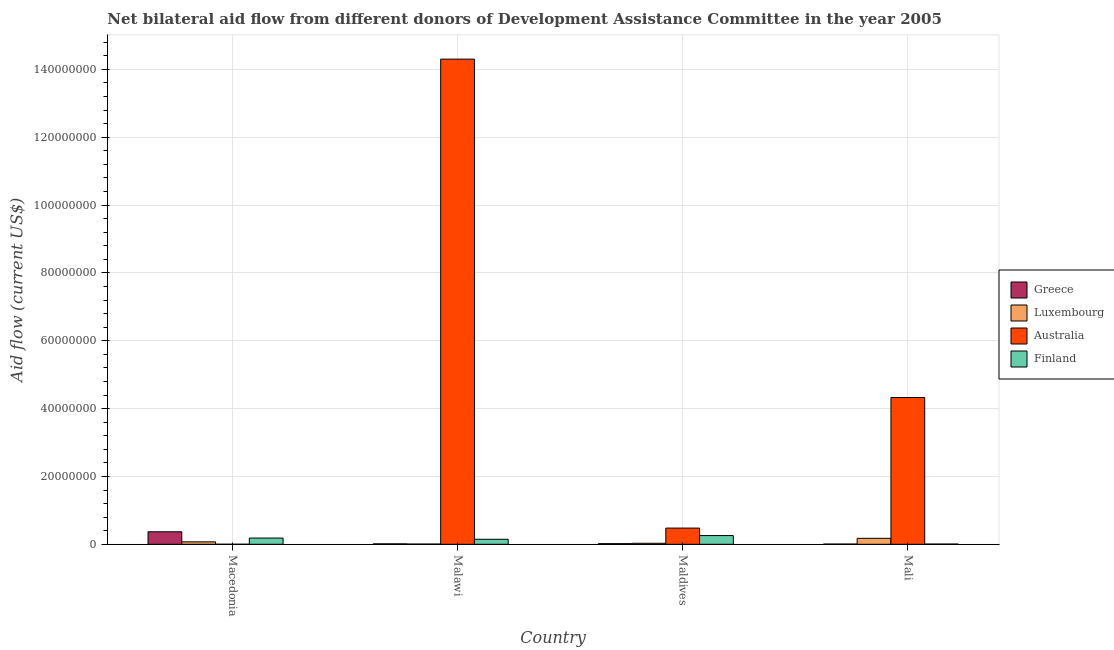Are the number of bars on each tick of the X-axis equal?
Keep it short and to the point. Yes. What is the label of the 2nd group of bars from the left?
Your answer should be very brief. Malawi. In how many cases, is the number of bars for a given country not equal to the number of legend labels?
Offer a very short reply. 0. What is the amount of aid given by finland in Macedonia?
Your answer should be compact. 1.84e+06. Across all countries, what is the maximum amount of aid given by australia?
Your answer should be very brief. 1.43e+08. Across all countries, what is the minimum amount of aid given by greece?
Your response must be concise. 7.00e+04. In which country was the amount of aid given by australia maximum?
Your answer should be compact. Malawi. In which country was the amount of aid given by finland minimum?
Your answer should be very brief. Mali. What is the total amount of aid given by australia in the graph?
Offer a very short reply. 1.91e+08. What is the difference between the amount of aid given by greece in Macedonia and that in Mali?
Your response must be concise. 3.62e+06. What is the difference between the amount of aid given by greece in Malawi and the amount of aid given by finland in Macedonia?
Offer a terse response. -1.71e+06. What is the average amount of aid given by greece per country?
Your answer should be compact. 1.02e+06. What is the difference between the amount of aid given by australia and amount of aid given by greece in Malawi?
Make the answer very short. 1.43e+08. In how many countries, is the amount of aid given by luxembourg greater than 124000000 US$?
Offer a terse response. 0. What is the ratio of the amount of aid given by finland in Macedonia to that in Malawi?
Offer a terse response. 1.24. What is the difference between the highest and the second highest amount of aid given by finland?
Provide a short and direct response. 7.30e+05. What is the difference between the highest and the lowest amount of aid given by finland?
Give a very brief answer. 2.50e+06. In how many countries, is the amount of aid given by finland greater than the average amount of aid given by finland taken over all countries?
Provide a short and direct response. 2. Is it the case that in every country, the sum of the amount of aid given by greece and amount of aid given by finland is greater than the sum of amount of aid given by luxembourg and amount of aid given by australia?
Your answer should be very brief. No. What does the 2nd bar from the right in Macedonia represents?
Offer a very short reply. Australia. Is it the case that in every country, the sum of the amount of aid given by greece and amount of aid given by luxembourg is greater than the amount of aid given by australia?
Your answer should be compact. No. How many bars are there?
Your answer should be very brief. 16. Are all the bars in the graph horizontal?
Your answer should be compact. No. How many countries are there in the graph?
Your answer should be very brief. 4. What is the difference between two consecutive major ticks on the Y-axis?
Your response must be concise. 2.00e+07. Does the graph contain any zero values?
Make the answer very short. No. Does the graph contain grids?
Give a very brief answer. Yes. How many legend labels are there?
Provide a short and direct response. 4. What is the title of the graph?
Your response must be concise. Net bilateral aid flow from different donors of Development Assistance Committee in the year 2005. Does "Trade" appear as one of the legend labels in the graph?
Keep it short and to the point. No. What is the label or title of the Y-axis?
Make the answer very short. Aid flow (current US$). What is the Aid flow (current US$) in Greece in Macedonia?
Ensure brevity in your answer.  3.69e+06. What is the Aid flow (current US$) of Luxembourg in Macedonia?
Provide a short and direct response. 7.20e+05. What is the Aid flow (current US$) of Australia in Macedonia?
Make the answer very short. 10000. What is the Aid flow (current US$) in Finland in Macedonia?
Make the answer very short. 1.84e+06. What is the Aid flow (current US$) in Greece in Malawi?
Offer a terse response. 1.30e+05. What is the Aid flow (current US$) in Luxembourg in Malawi?
Keep it short and to the point. 7.00e+04. What is the Aid flow (current US$) in Australia in Malawi?
Offer a terse response. 1.43e+08. What is the Aid flow (current US$) of Finland in Malawi?
Provide a short and direct response. 1.48e+06. What is the Aid flow (current US$) in Australia in Maldives?
Your answer should be compact. 4.78e+06. What is the Aid flow (current US$) in Finland in Maldives?
Your response must be concise. 2.57e+06. What is the Aid flow (current US$) in Luxembourg in Mali?
Offer a very short reply. 1.76e+06. What is the Aid flow (current US$) in Australia in Mali?
Your answer should be very brief. 4.33e+07. What is the Aid flow (current US$) in Finland in Mali?
Offer a very short reply. 7.00e+04. Across all countries, what is the maximum Aid flow (current US$) in Greece?
Ensure brevity in your answer.  3.69e+06. Across all countries, what is the maximum Aid flow (current US$) of Luxembourg?
Offer a terse response. 1.76e+06. Across all countries, what is the maximum Aid flow (current US$) of Australia?
Keep it short and to the point. 1.43e+08. Across all countries, what is the maximum Aid flow (current US$) of Finland?
Ensure brevity in your answer.  2.57e+06. Across all countries, what is the minimum Aid flow (current US$) in Greece?
Offer a very short reply. 7.00e+04. Across all countries, what is the minimum Aid flow (current US$) in Australia?
Provide a succinct answer. 10000. Across all countries, what is the minimum Aid flow (current US$) in Finland?
Provide a succinct answer. 7.00e+04. What is the total Aid flow (current US$) in Greece in the graph?
Offer a very short reply. 4.08e+06. What is the total Aid flow (current US$) of Luxembourg in the graph?
Ensure brevity in your answer.  2.85e+06. What is the total Aid flow (current US$) in Australia in the graph?
Keep it short and to the point. 1.91e+08. What is the total Aid flow (current US$) in Finland in the graph?
Offer a terse response. 5.96e+06. What is the difference between the Aid flow (current US$) of Greece in Macedonia and that in Malawi?
Offer a terse response. 3.56e+06. What is the difference between the Aid flow (current US$) of Luxembourg in Macedonia and that in Malawi?
Ensure brevity in your answer.  6.50e+05. What is the difference between the Aid flow (current US$) of Australia in Macedonia and that in Malawi?
Provide a succinct answer. -1.43e+08. What is the difference between the Aid flow (current US$) of Greece in Macedonia and that in Maldives?
Your answer should be compact. 3.50e+06. What is the difference between the Aid flow (current US$) of Luxembourg in Macedonia and that in Maldives?
Give a very brief answer. 4.20e+05. What is the difference between the Aid flow (current US$) in Australia in Macedonia and that in Maldives?
Ensure brevity in your answer.  -4.77e+06. What is the difference between the Aid flow (current US$) of Finland in Macedonia and that in Maldives?
Give a very brief answer. -7.30e+05. What is the difference between the Aid flow (current US$) in Greece in Macedonia and that in Mali?
Give a very brief answer. 3.62e+06. What is the difference between the Aid flow (current US$) in Luxembourg in Macedonia and that in Mali?
Your response must be concise. -1.04e+06. What is the difference between the Aid flow (current US$) in Australia in Macedonia and that in Mali?
Provide a short and direct response. -4.33e+07. What is the difference between the Aid flow (current US$) of Finland in Macedonia and that in Mali?
Ensure brevity in your answer.  1.77e+06. What is the difference between the Aid flow (current US$) in Luxembourg in Malawi and that in Maldives?
Keep it short and to the point. -2.30e+05. What is the difference between the Aid flow (current US$) of Australia in Malawi and that in Maldives?
Your response must be concise. 1.38e+08. What is the difference between the Aid flow (current US$) of Finland in Malawi and that in Maldives?
Your response must be concise. -1.09e+06. What is the difference between the Aid flow (current US$) of Greece in Malawi and that in Mali?
Provide a succinct answer. 6.00e+04. What is the difference between the Aid flow (current US$) of Luxembourg in Malawi and that in Mali?
Keep it short and to the point. -1.69e+06. What is the difference between the Aid flow (current US$) in Australia in Malawi and that in Mali?
Provide a succinct answer. 9.98e+07. What is the difference between the Aid flow (current US$) in Finland in Malawi and that in Mali?
Offer a terse response. 1.41e+06. What is the difference between the Aid flow (current US$) of Greece in Maldives and that in Mali?
Keep it short and to the point. 1.20e+05. What is the difference between the Aid flow (current US$) in Luxembourg in Maldives and that in Mali?
Offer a terse response. -1.46e+06. What is the difference between the Aid flow (current US$) of Australia in Maldives and that in Mali?
Keep it short and to the point. -3.85e+07. What is the difference between the Aid flow (current US$) of Finland in Maldives and that in Mali?
Your answer should be very brief. 2.50e+06. What is the difference between the Aid flow (current US$) in Greece in Macedonia and the Aid flow (current US$) in Luxembourg in Malawi?
Provide a succinct answer. 3.62e+06. What is the difference between the Aid flow (current US$) in Greece in Macedonia and the Aid flow (current US$) in Australia in Malawi?
Provide a succinct answer. -1.39e+08. What is the difference between the Aid flow (current US$) of Greece in Macedonia and the Aid flow (current US$) of Finland in Malawi?
Offer a very short reply. 2.21e+06. What is the difference between the Aid flow (current US$) in Luxembourg in Macedonia and the Aid flow (current US$) in Australia in Malawi?
Your response must be concise. -1.42e+08. What is the difference between the Aid flow (current US$) in Luxembourg in Macedonia and the Aid flow (current US$) in Finland in Malawi?
Make the answer very short. -7.60e+05. What is the difference between the Aid flow (current US$) in Australia in Macedonia and the Aid flow (current US$) in Finland in Malawi?
Your response must be concise. -1.47e+06. What is the difference between the Aid flow (current US$) of Greece in Macedonia and the Aid flow (current US$) of Luxembourg in Maldives?
Provide a short and direct response. 3.39e+06. What is the difference between the Aid flow (current US$) in Greece in Macedonia and the Aid flow (current US$) in Australia in Maldives?
Offer a very short reply. -1.09e+06. What is the difference between the Aid flow (current US$) in Greece in Macedonia and the Aid flow (current US$) in Finland in Maldives?
Provide a succinct answer. 1.12e+06. What is the difference between the Aid flow (current US$) of Luxembourg in Macedonia and the Aid flow (current US$) of Australia in Maldives?
Offer a terse response. -4.06e+06. What is the difference between the Aid flow (current US$) in Luxembourg in Macedonia and the Aid flow (current US$) in Finland in Maldives?
Provide a short and direct response. -1.85e+06. What is the difference between the Aid flow (current US$) of Australia in Macedonia and the Aid flow (current US$) of Finland in Maldives?
Offer a very short reply. -2.56e+06. What is the difference between the Aid flow (current US$) of Greece in Macedonia and the Aid flow (current US$) of Luxembourg in Mali?
Provide a succinct answer. 1.93e+06. What is the difference between the Aid flow (current US$) in Greece in Macedonia and the Aid flow (current US$) in Australia in Mali?
Your answer should be compact. -3.96e+07. What is the difference between the Aid flow (current US$) of Greece in Macedonia and the Aid flow (current US$) of Finland in Mali?
Your answer should be very brief. 3.62e+06. What is the difference between the Aid flow (current US$) in Luxembourg in Macedonia and the Aid flow (current US$) in Australia in Mali?
Provide a succinct answer. -4.26e+07. What is the difference between the Aid flow (current US$) in Luxembourg in Macedonia and the Aid flow (current US$) in Finland in Mali?
Provide a short and direct response. 6.50e+05. What is the difference between the Aid flow (current US$) in Greece in Malawi and the Aid flow (current US$) in Australia in Maldives?
Provide a succinct answer. -4.65e+06. What is the difference between the Aid flow (current US$) in Greece in Malawi and the Aid flow (current US$) in Finland in Maldives?
Give a very brief answer. -2.44e+06. What is the difference between the Aid flow (current US$) of Luxembourg in Malawi and the Aid flow (current US$) of Australia in Maldives?
Your response must be concise. -4.71e+06. What is the difference between the Aid flow (current US$) of Luxembourg in Malawi and the Aid flow (current US$) of Finland in Maldives?
Ensure brevity in your answer.  -2.50e+06. What is the difference between the Aid flow (current US$) of Australia in Malawi and the Aid flow (current US$) of Finland in Maldives?
Provide a short and direct response. 1.40e+08. What is the difference between the Aid flow (current US$) in Greece in Malawi and the Aid flow (current US$) in Luxembourg in Mali?
Make the answer very short. -1.63e+06. What is the difference between the Aid flow (current US$) in Greece in Malawi and the Aid flow (current US$) in Australia in Mali?
Provide a short and direct response. -4.31e+07. What is the difference between the Aid flow (current US$) of Luxembourg in Malawi and the Aid flow (current US$) of Australia in Mali?
Ensure brevity in your answer.  -4.32e+07. What is the difference between the Aid flow (current US$) of Australia in Malawi and the Aid flow (current US$) of Finland in Mali?
Provide a short and direct response. 1.43e+08. What is the difference between the Aid flow (current US$) in Greece in Maldives and the Aid flow (current US$) in Luxembourg in Mali?
Offer a very short reply. -1.57e+06. What is the difference between the Aid flow (current US$) in Greece in Maldives and the Aid flow (current US$) in Australia in Mali?
Ensure brevity in your answer.  -4.31e+07. What is the difference between the Aid flow (current US$) of Greece in Maldives and the Aid flow (current US$) of Finland in Mali?
Give a very brief answer. 1.20e+05. What is the difference between the Aid flow (current US$) in Luxembourg in Maldives and the Aid flow (current US$) in Australia in Mali?
Give a very brief answer. -4.30e+07. What is the difference between the Aid flow (current US$) in Luxembourg in Maldives and the Aid flow (current US$) in Finland in Mali?
Provide a succinct answer. 2.30e+05. What is the difference between the Aid flow (current US$) of Australia in Maldives and the Aid flow (current US$) of Finland in Mali?
Provide a succinct answer. 4.71e+06. What is the average Aid flow (current US$) in Greece per country?
Keep it short and to the point. 1.02e+06. What is the average Aid flow (current US$) in Luxembourg per country?
Offer a terse response. 7.12e+05. What is the average Aid flow (current US$) of Australia per country?
Provide a succinct answer. 4.78e+07. What is the average Aid flow (current US$) in Finland per country?
Give a very brief answer. 1.49e+06. What is the difference between the Aid flow (current US$) in Greece and Aid flow (current US$) in Luxembourg in Macedonia?
Keep it short and to the point. 2.97e+06. What is the difference between the Aid flow (current US$) of Greece and Aid flow (current US$) of Australia in Macedonia?
Give a very brief answer. 3.68e+06. What is the difference between the Aid flow (current US$) of Greece and Aid flow (current US$) of Finland in Macedonia?
Your answer should be very brief. 1.85e+06. What is the difference between the Aid flow (current US$) of Luxembourg and Aid flow (current US$) of Australia in Macedonia?
Your answer should be very brief. 7.10e+05. What is the difference between the Aid flow (current US$) of Luxembourg and Aid flow (current US$) of Finland in Macedonia?
Make the answer very short. -1.12e+06. What is the difference between the Aid flow (current US$) of Australia and Aid flow (current US$) of Finland in Macedonia?
Provide a succinct answer. -1.83e+06. What is the difference between the Aid flow (current US$) of Greece and Aid flow (current US$) of Luxembourg in Malawi?
Your answer should be compact. 6.00e+04. What is the difference between the Aid flow (current US$) in Greece and Aid flow (current US$) in Australia in Malawi?
Keep it short and to the point. -1.43e+08. What is the difference between the Aid flow (current US$) of Greece and Aid flow (current US$) of Finland in Malawi?
Give a very brief answer. -1.35e+06. What is the difference between the Aid flow (current US$) of Luxembourg and Aid flow (current US$) of Australia in Malawi?
Offer a very short reply. -1.43e+08. What is the difference between the Aid flow (current US$) in Luxembourg and Aid flow (current US$) in Finland in Malawi?
Your answer should be compact. -1.41e+06. What is the difference between the Aid flow (current US$) of Australia and Aid flow (current US$) of Finland in Malawi?
Your answer should be very brief. 1.42e+08. What is the difference between the Aid flow (current US$) of Greece and Aid flow (current US$) of Luxembourg in Maldives?
Offer a very short reply. -1.10e+05. What is the difference between the Aid flow (current US$) in Greece and Aid flow (current US$) in Australia in Maldives?
Your response must be concise. -4.59e+06. What is the difference between the Aid flow (current US$) in Greece and Aid flow (current US$) in Finland in Maldives?
Provide a short and direct response. -2.38e+06. What is the difference between the Aid flow (current US$) in Luxembourg and Aid flow (current US$) in Australia in Maldives?
Offer a terse response. -4.48e+06. What is the difference between the Aid flow (current US$) of Luxembourg and Aid flow (current US$) of Finland in Maldives?
Offer a very short reply. -2.27e+06. What is the difference between the Aid flow (current US$) of Australia and Aid flow (current US$) of Finland in Maldives?
Ensure brevity in your answer.  2.21e+06. What is the difference between the Aid flow (current US$) in Greece and Aid flow (current US$) in Luxembourg in Mali?
Your response must be concise. -1.69e+06. What is the difference between the Aid flow (current US$) in Greece and Aid flow (current US$) in Australia in Mali?
Provide a short and direct response. -4.32e+07. What is the difference between the Aid flow (current US$) of Luxembourg and Aid flow (current US$) of Australia in Mali?
Your answer should be compact. -4.15e+07. What is the difference between the Aid flow (current US$) in Luxembourg and Aid flow (current US$) in Finland in Mali?
Provide a short and direct response. 1.69e+06. What is the difference between the Aid flow (current US$) of Australia and Aid flow (current US$) of Finland in Mali?
Your answer should be compact. 4.32e+07. What is the ratio of the Aid flow (current US$) in Greece in Macedonia to that in Malawi?
Provide a short and direct response. 28.38. What is the ratio of the Aid flow (current US$) of Luxembourg in Macedonia to that in Malawi?
Provide a succinct answer. 10.29. What is the ratio of the Aid flow (current US$) in Australia in Macedonia to that in Malawi?
Your answer should be very brief. 0. What is the ratio of the Aid flow (current US$) of Finland in Macedonia to that in Malawi?
Keep it short and to the point. 1.24. What is the ratio of the Aid flow (current US$) of Greece in Macedonia to that in Maldives?
Your answer should be very brief. 19.42. What is the ratio of the Aid flow (current US$) in Australia in Macedonia to that in Maldives?
Make the answer very short. 0. What is the ratio of the Aid flow (current US$) in Finland in Macedonia to that in Maldives?
Provide a succinct answer. 0.72. What is the ratio of the Aid flow (current US$) in Greece in Macedonia to that in Mali?
Offer a terse response. 52.71. What is the ratio of the Aid flow (current US$) in Luxembourg in Macedonia to that in Mali?
Your answer should be very brief. 0.41. What is the ratio of the Aid flow (current US$) of Finland in Macedonia to that in Mali?
Your answer should be compact. 26.29. What is the ratio of the Aid flow (current US$) of Greece in Malawi to that in Maldives?
Your answer should be very brief. 0.68. What is the ratio of the Aid flow (current US$) of Luxembourg in Malawi to that in Maldives?
Provide a succinct answer. 0.23. What is the ratio of the Aid flow (current US$) of Australia in Malawi to that in Maldives?
Provide a succinct answer. 29.92. What is the ratio of the Aid flow (current US$) in Finland in Malawi to that in Maldives?
Keep it short and to the point. 0.58. What is the ratio of the Aid flow (current US$) in Greece in Malawi to that in Mali?
Offer a terse response. 1.86. What is the ratio of the Aid flow (current US$) in Luxembourg in Malawi to that in Mali?
Your answer should be compact. 0.04. What is the ratio of the Aid flow (current US$) of Australia in Malawi to that in Mali?
Ensure brevity in your answer.  3.31. What is the ratio of the Aid flow (current US$) in Finland in Malawi to that in Mali?
Keep it short and to the point. 21.14. What is the ratio of the Aid flow (current US$) in Greece in Maldives to that in Mali?
Your answer should be very brief. 2.71. What is the ratio of the Aid flow (current US$) of Luxembourg in Maldives to that in Mali?
Your answer should be very brief. 0.17. What is the ratio of the Aid flow (current US$) of Australia in Maldives to that in Mali?
Give a very brief answer. 0.11. What is the ratio of the Aid flow (current US$) in Finland in Maldives to that in Mali?
Offer a very short reply. 36.71. What is the difference between the highest and the second highest Aid flow (current US$) in Greece?
Your answer should be compact. 3.50e+06. What is the difference between the highest and the second highest Aid flow (current US$) of Luxembourg?
Make the answer very short. 1.04e+06. What is the difference between the highest and the second highest Aid flow (current US$) in Australia?
Keep it short and to the point. 9.98e+07. What is the difference between the highest and the second highest Aid flow (current US$) in Finland?
Your answer should be very brief. 7.30e+05. What is the difference between the highest and the lowest Aid flow (current US$) of Greece?
Give a very brief answer. 3.62e+06. What is the difference between the highest and the lowest Aid flow (current US$) in Luxembourg?
Make the answer very short. 1.69e+06. What is the difference between the highest and the lowest Aid flow (current US$) of Australia?
Your response must be concise. 1.43e+08. What is the difference between the highest and the lowest Aid flow (current US$) of Finland?
Provide a short and direct response. 2.50e+06. 